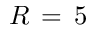Convert formula to latex. <formula><loc_0><loc_0><loc_500><loc_500>R \, = \, 5</formula> 